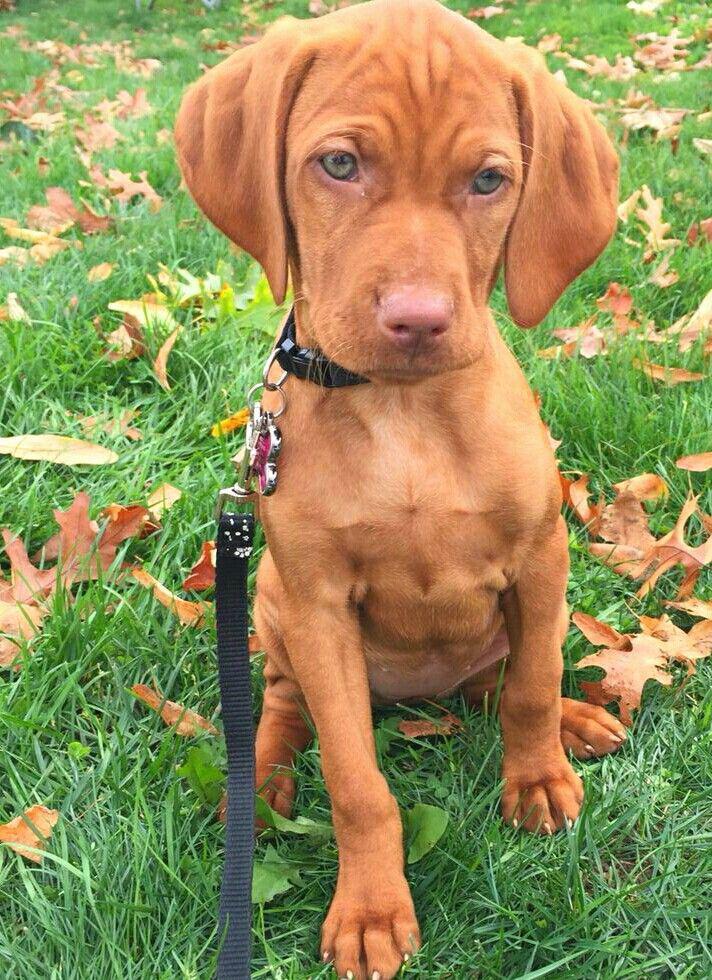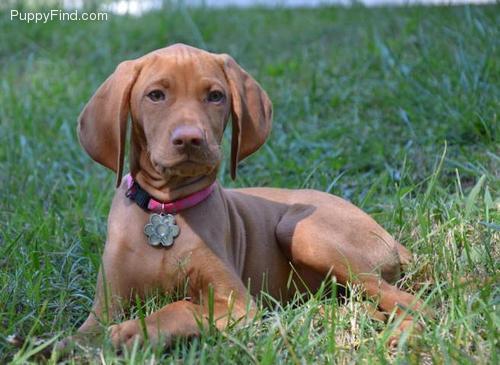The first image is the image on the left, the second image is the image on the right. Analyze the images presented: Is the assertion "A dog is sitting with one paw in front of the other paw." valid? Answer yes or no. Yes. The first image is the image on the left, the second image is the image on the right. Evaluate the accuracy of this statement regarding the images: "The left image includes a puppy sitting upright and facing forward, and the right image contains one dog in a reclining pose on grass, with its head facing forward.". Is it true? Answer yes or no. Yes. 